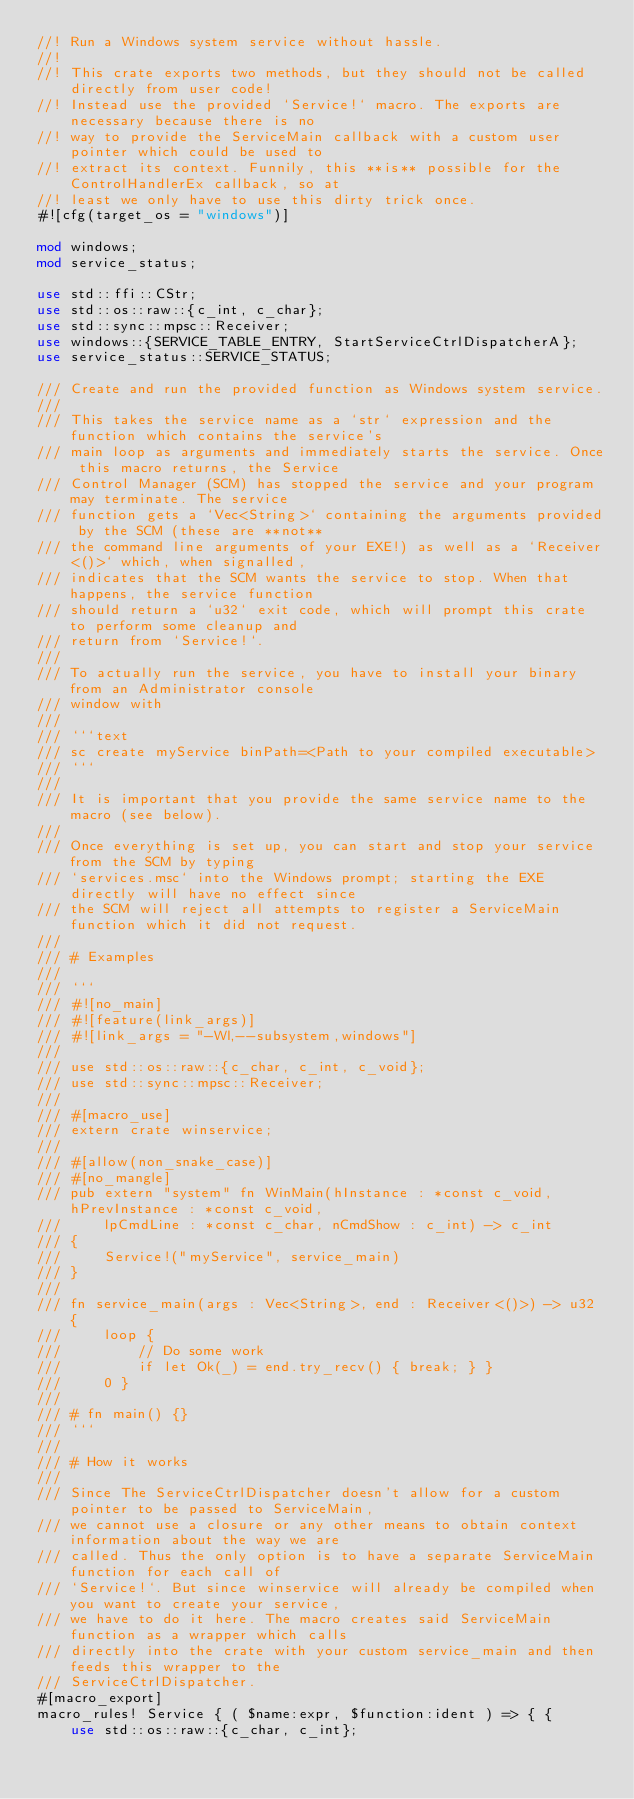Convert code to text. <code><loc_0><loc_0><loc_500><loc_500><_Rust_>//! Run a Windows system service without hassle.
//!
//! This crate exports two methods, but they should not be called directly from user code!
//! Instead use the provided `Service!` macro. The exports are necessary because there is no
//! way to provide the ServiceMain callback with a custom user pointer which could be used to
//! extract its context. Funnily, this **is** possible for the ControlHandlerEx callback, so at
//! least we only have to use this dirty trick once.
#![cfg(target_os = "windows")]

mod windows;
mod service_status;

use std::ffi::CStr;
use std::os::raw::{c_int, c_char};
use std::sync::mpsc::Receiver;
use windows::{SERVICE_TABLE_ENTRY, StartServiceCtrlDispatcherA};
use service_status::SERVICE_STATUS;

/// Create and run the provided function as Windows system service.
///
/// This takes the service name as a `str` expression and the function which contains the service's
/// main loop as arguments and immediately starts the service. Once this macro returns, the Service
/// Control Manager (SCM) has stopped the service and your program may terminate. The service
/// function gets a `Vec<String>` containing the arguments provided by the SCM (these are **not**
/// the command line arguments of your EXE!) as well as a `Receiver<()>` which, when signalled,
/// indicates that the SCM wants the service to stop. When that happens, the service function
/// should return a `u32` exit code, which will prompt this crate to perform some cleanup and
/// return from `Service!`.
///
/// To actually run the service, you have to install your binary from an Administrator console
/// window with
///
/// ```text
/// sc create myService binPath=<Path to your compiled executable>
/// ```
///
/// It is important that you provide the same service name to the macro (see below).
///
/// Once everything is set up, you can start and stop your service from the SCM by typing
/// `services.msc` into the Windows prompt; starting the EXE directly will have no effect since
/// the SCM will reject all attempts to register a ServiceMain function which it did not request.
///
/// # Examples
///
/// ```
/// #![no_main]
/// #![feature(link_args)]
/// #![link_args = "-Wl,--subsystem,windows"]
///
/// use std::os::raw::{c_char, c_int, c_void};
/// use std::sync::mpsc::Receiver;
///
/// #[macro_use]
/// extern crate winservice;
///
/// #[allow(non_snake_case)]
/// #[no_mangle]
/// pub extern "system" fn WinMain(hInstance : *const c_void, hPrevInstance : *const c_void,
///     lpCmdLine : *const c_char, nCmdShow : c_int) -> c_int
/// {
///     Service!("myService", service_main)
/// }
///
/// fn service_main(args : Vec<String>, end : Receiver<()>) -> u32 {
///     loop {
///         // Do some work
///         if let Ok(_) = end.try_recv() { break; } }
///     0 }
///
/// # fn main() {}
/// ```
///
/// # How it works
///
/// Since The ServiceCtrlDispatcher doesn't allow for a custom pointer to be passed to ServiceMain,
/// we cannot use a closure or any other means to obtain context information about the way we are
/// called. Thus the only option is to have a separate ServiceMain function for each call of
/// `Service!`. But since winservice will already be compiled when you want to create your service,
/// we have to do it here. The macro creates said ServiceMain function as a wrapper which calls
/// directly into the crate with your custom service_main and then feeds this wrapper to the
/// ServiceCtrlDispatcher.
#[macro_export]
macro_rules! Service { ( $name:expr, $function:ident ) => { {
    use std::os::raw::{c_char, c_int};</code> 